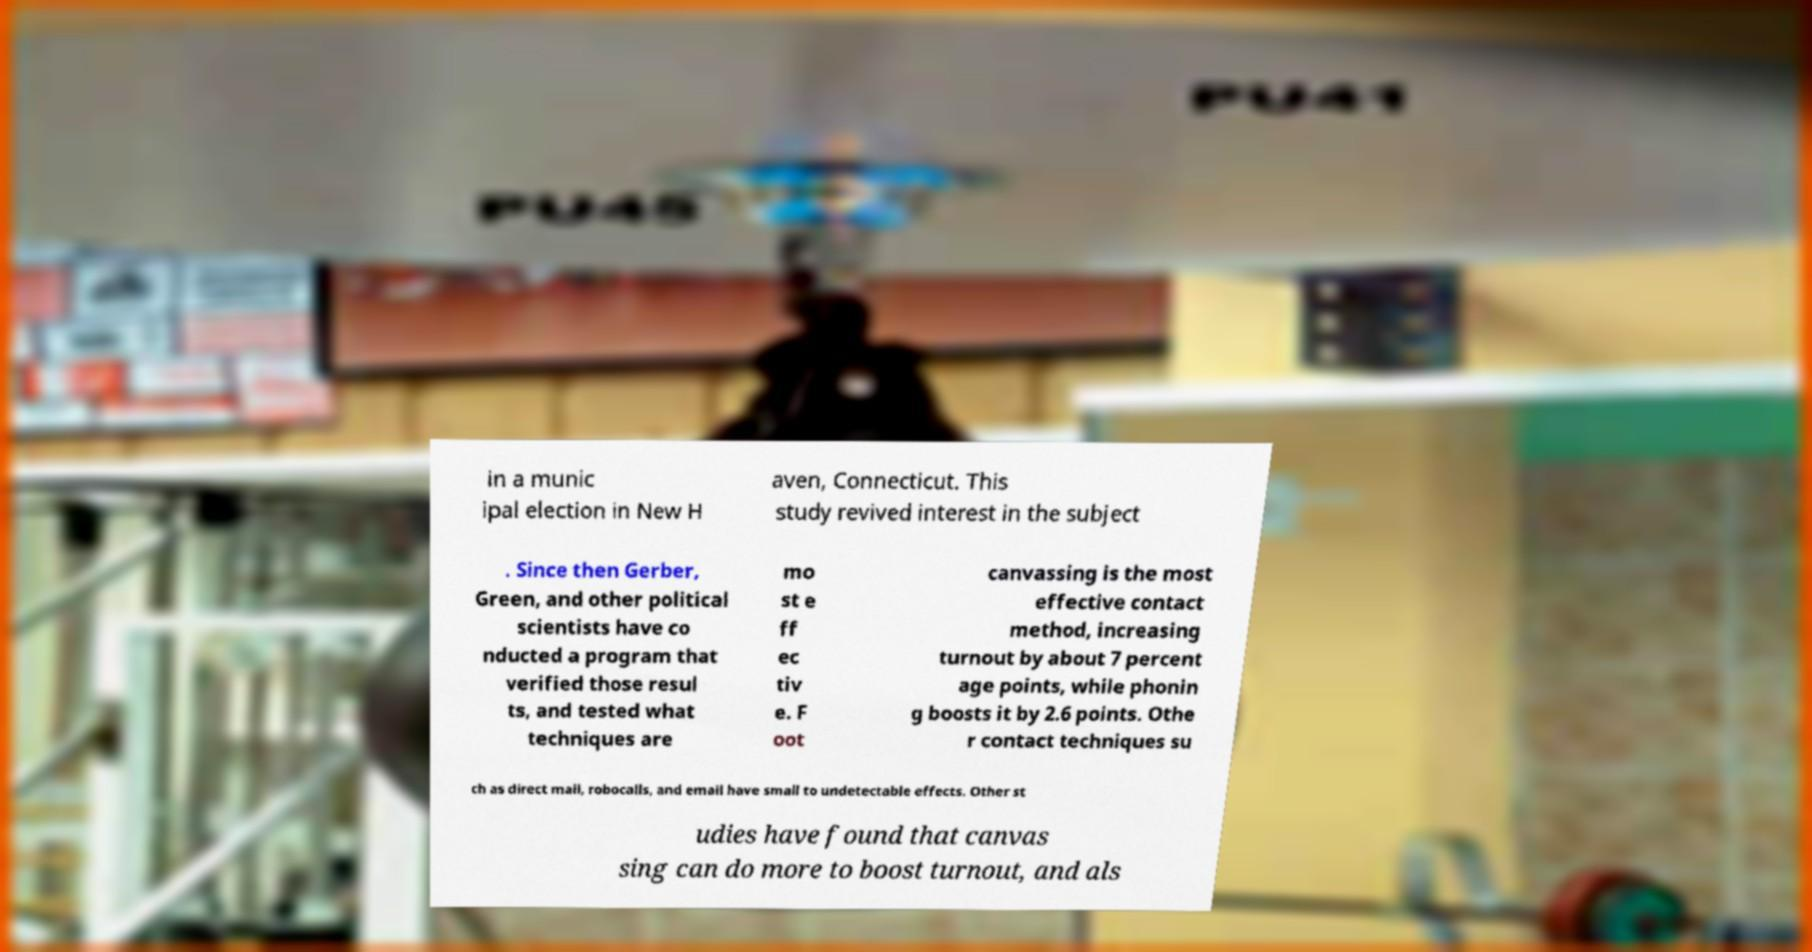Can you accurately transcribe the text from the provided image for me? in a munic ipal election in New H aven, Connecticut. This study revived interest in the subject . Since then Gerber, Green, and other political scientists have co nducted a program that verified those resul ts, and tested what techniques are mo st e ff ec tiv e. F oot canvassing is the most effective contact method, increasing turnout by about 7 percent age points, while phonin g boosts it by 2.6 points. Othe r contact techniques su ch as direct mail, robocalls, and email have small to undetectable effects. Other st udies have found that canvas sing can do more to boost turnout, and als 